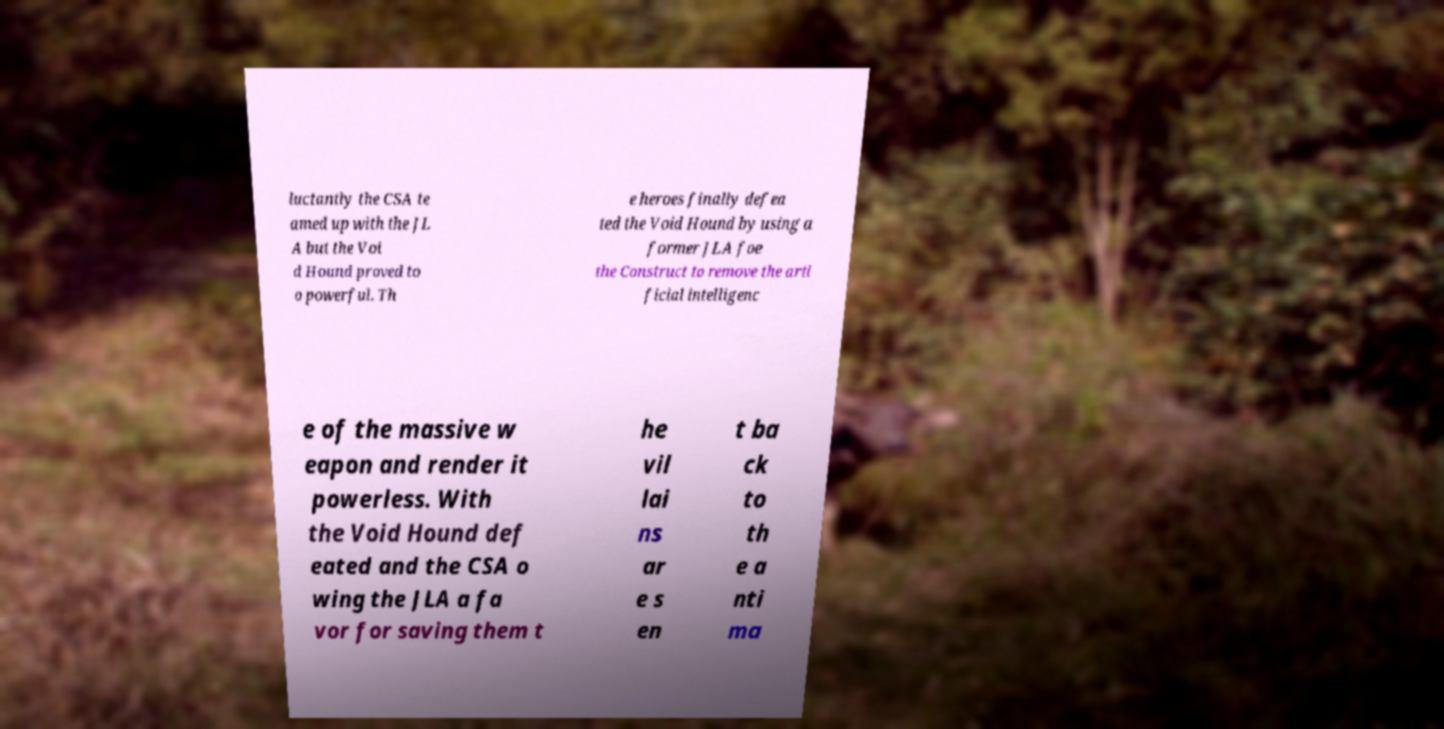What messages or text are displayed in this image? I need them in a readable, typed format. luctantly the CSA te amed up with the JL A but the Voi d Hound proved to o powerful. Th e heroes finally defea ted the Void Hound by using a former JLA foe the Construct to remove the arti ficial intelligenc e of the massive w eapon and render it powerless. With the Void Hound def eated and the CSA o wing the JLA a fa vor for saving them t he vil lai ns ar e s en t ba ck to th e a nti ma 